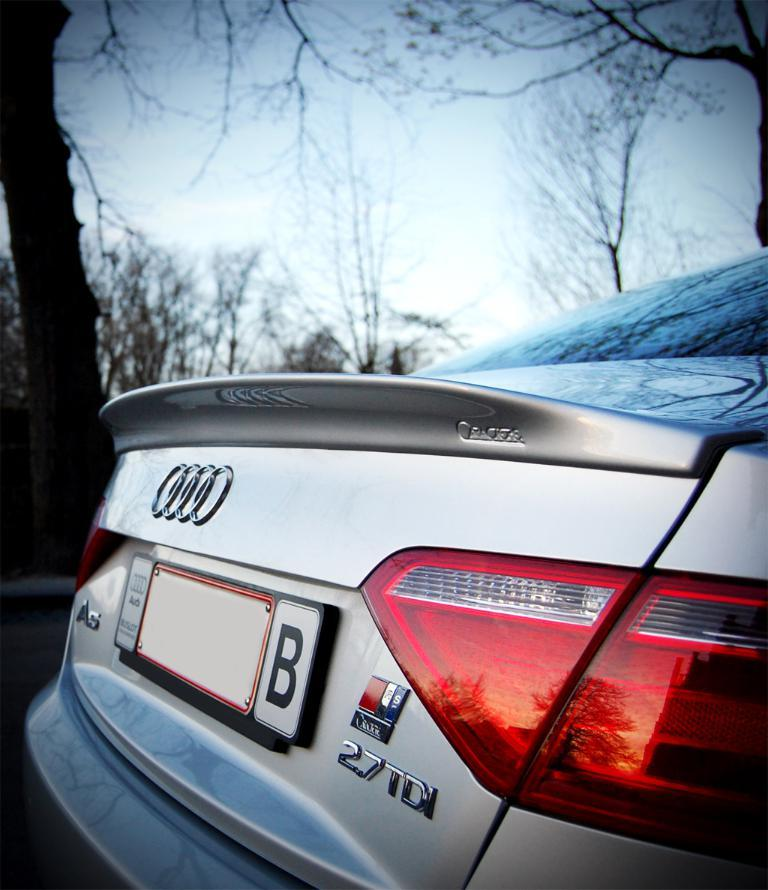Provide a one-sentence caption for the provided image. An Audi 27TDI is photographed from the trunk side. 